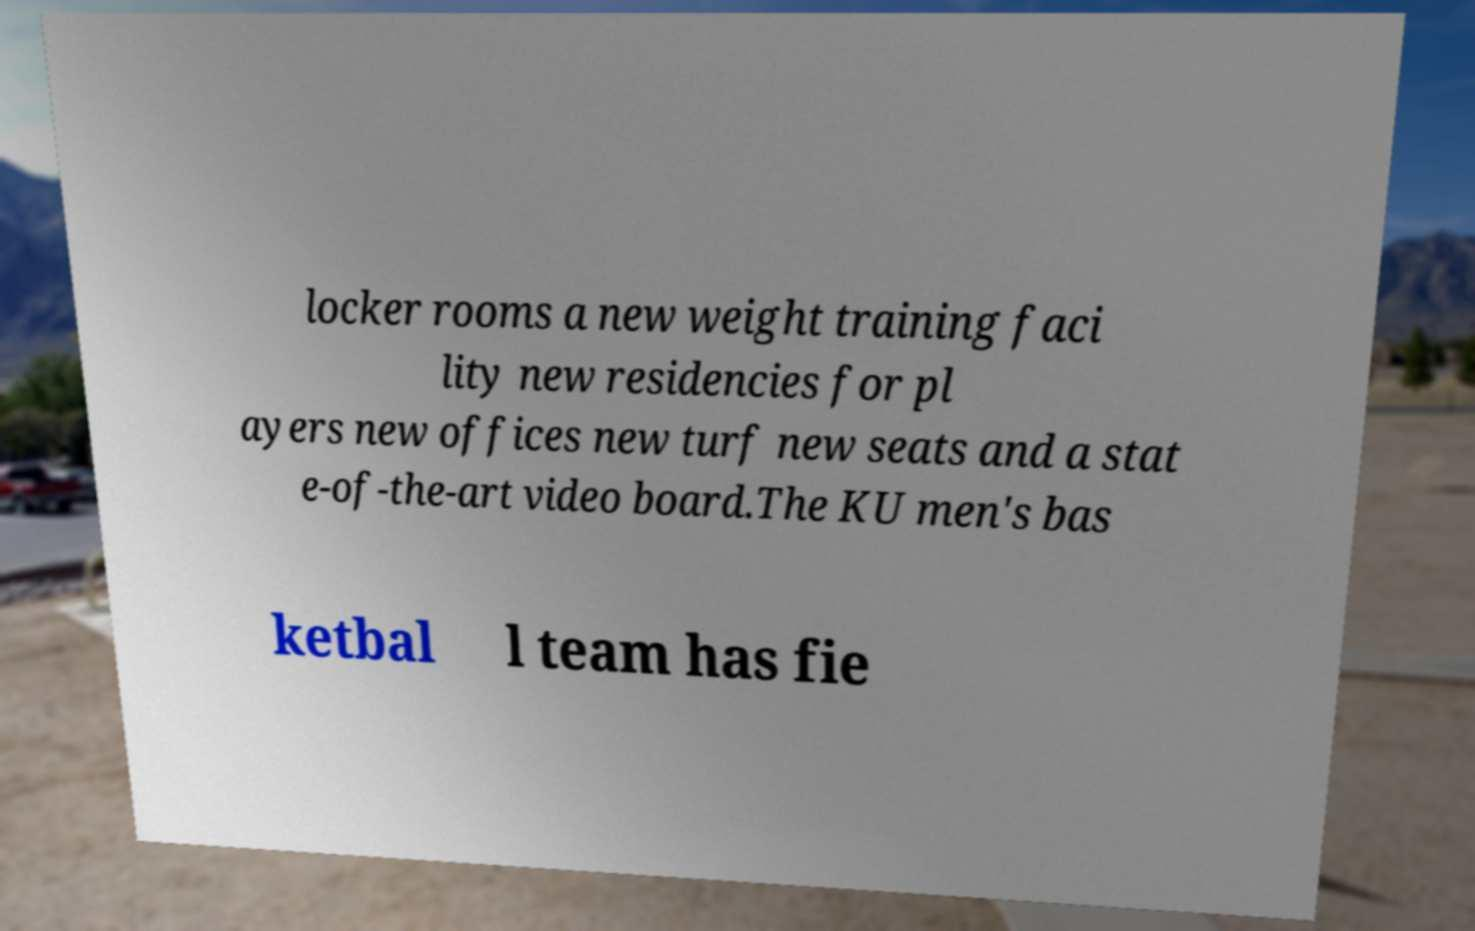Could you extract and type out the text from this image? locker rooms a new weight training faci lity new residencies for pl ayers new offices new turf new seats and a stat e-of-the-art video board.The KU men's bas ketbal l team has fie 